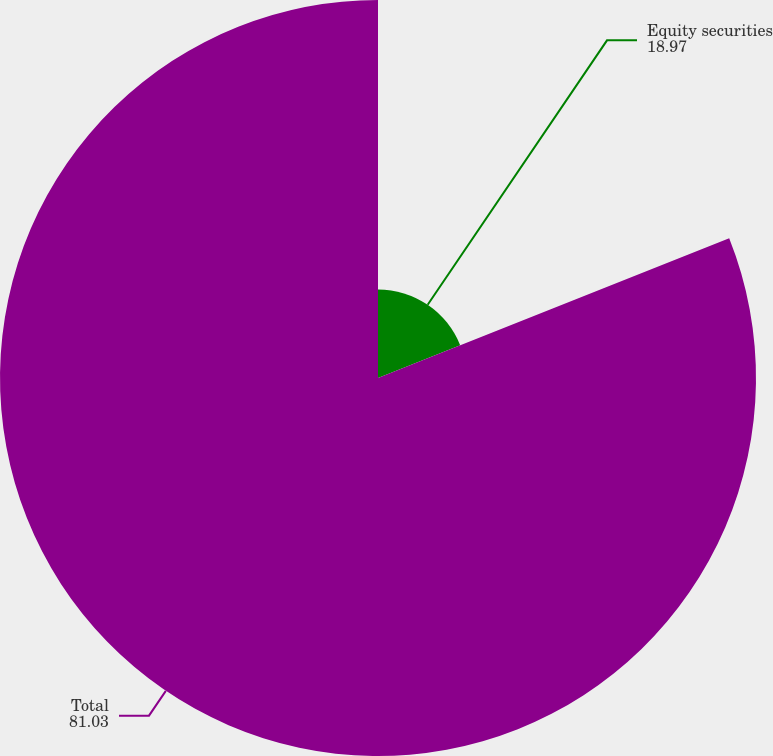Convert chart. <chart><loc_0><loc_0><loc_500><loc_500><pie_chart><fcel>Equity securities<fcel>Total<nl><fcel>18.97%<fcel>81.03%<nl></chart> 